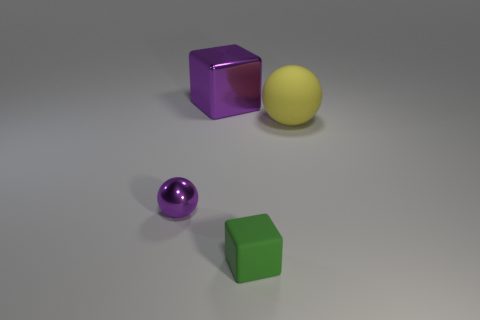Add 3 big red cylinders. How many objects exist? 7 Subtract 1 purple blocks. How many objects are left? 3 Subtract all red shiny objects. Subtract all big yellow spheres. How many objects are left? 3 Add 3 tiny green things. How many tiny green things are left? 4 Add 4 small objects. How many small objects exist? 6 